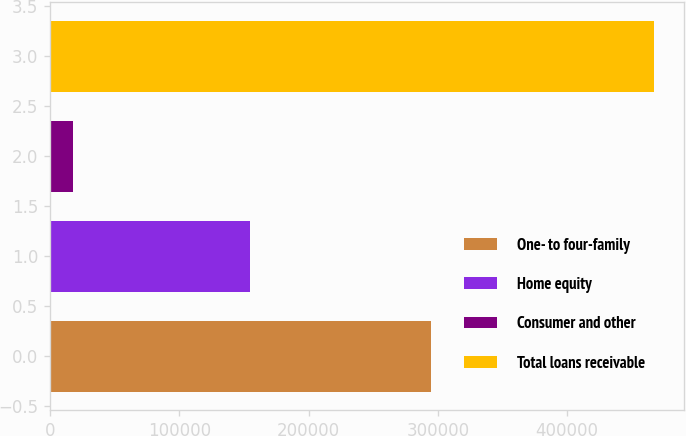Convert chart. <chart><loc_0><loc_0><loc_500><loc_500><bar_chart><fcel>One- to four-family<fcel>Home equity<fcel>Consumer and other<fcel>Total loans receivable<nl><fcel>294769<fcel>154638<fcel>17715<fcel>467122<nl></chart> 